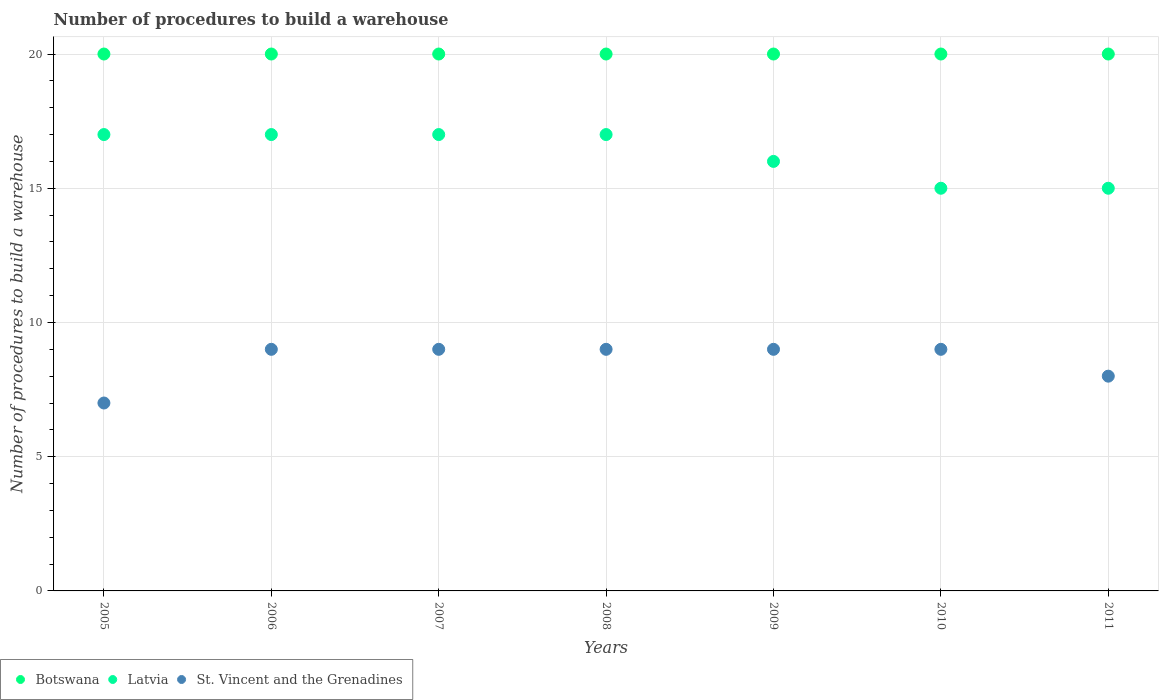Is the number of dotlines equal to the number of legend labels?
Give a very brief answer. Yes. What is the number of procedures to build a warehouse in in Botswana in 2005?
Offer a very short reply. 20. Across all years, what is the maximum number of procedures to build a warehouse in in Latvia?
Your response must be concise. 17. Across all years, what is the minimum number of procedures to build a warehouse in in Latvia?
Ensure brevity in your answer.  15. What is the total number of procedures to build a warehouse in in Latvia in the graph?
Your response must be concise. 114. What is the difference between the number of procedures to build a warehouse in in Latvia in 2011 and the number of procedures to build a warehouse in in Botswana in 2010?
Your answer should be compact. -5. What is the average number of procedures to build a warehouse in in Latvia per year?
Provide a short and direct response. 16.29. In the year 2005, what is the difference between the number of procedures to build a warehouse in in St. Vincent and the Grenadines and number of procedures to build a warehouse in in Latvia?
Keep it short and to the point. -10. In how many years, is the number of procedures to build a warehouse in in Latvia greater than 2?
Ensure brevity in your answer.  7. What is the ratio of the number of procedures to build a warehouse in in Latvia in 2007 to that in 2008?
Give a very brief answer. 1. What is the difference between the highest and the second highest number of procedures to build a warehouse in in Botswana?
Offer a very short reply. 0. What is the difference between the highest and the lowest number of procedures to build a warehouse in in Botswana?
Offer a terse response. 0. Does the number of procedures to build a warehouse in in Botswana monotonically increase over the years?
Offer a very short reply. No. Is the number of procedures to build a warehouse in in Latvia strictly less than the number of procedures to build a warehouse in in Botswana over the years?
Offer a very short reply. Yes. What is the difference between two consecutive major ticks on the Y-axis?
Give a very brief answer. 5. Are the values on the major ticks of Y-axis written in scientific E-notation?
Your answer should be compact. No. Does the graph contain any zero values?
Your response must be concise. No. How are the legend labels stacked?
Your response must be concise. Horizontal. What is the title of the graph?
Your answer should be very brief. Number of procedures to build a warehouse. Does "Heavily indebted poor countries" appear as one of the legend labels in the graph?
Give a very brief answer. No. What is the label or title of the Y-axis?
Give a very brief answer. Number of procedures to build a warehouse. What is the Number of procedures to build a warehouse in St. Vincent and the Grenadines in 2005?
Offer a very short reply. 7. What is the Number of procedures to build a warehouse in Botswana in 2006?
Provide a short and direct response. 20. What is the Number of procedures to build a warehouse of Latvia in 2006?
Provide a short and direct response. 17. What is the Number of procedures to build a warehouse in St. Vincent and the Grenadines in 2006?
Keep it short and to the point. 9. What is the Number of procedures to build a warehouse in Botswana in 2007?
Your answer should be very brief. 20. What is the Number of procedures to build a warehouse in Latvia in 2007?
Ensure brevity in your answer.  17. What is the Number of procedures to build a warehouse of St. Vincent and the Grenadines in 2007?
Give a very brief answer. 9. What is the Number of procedures to build a warehouse in St. Vincent and the Grenadines in 2009?
Your answer should be compact. 9. What is the Number of procedures to build a warehouse in Latvia in 2010?
Your response must be concise. 15. What is the Number of procedures to build a warehouse in Botswana in 2011?
Give a very brief answer. 20. What is the Number of procedures to build a warehouse of Latvia in 2011?
Provide a short and direct response. 15. Across all years, what is the maximum Number of procedures to build a warehouse of Latvia?
Provide a succinct answer. 17. Across all years, what is the maximum Number of procedures to build a warehouse in St. Vincent and the Grenadines?
Make the answer very short. 9. Across all years, what is the minimum Number of procedures to build a warehouse of Botswana?
Offer a terse response. 20. What is the total Number of procedures to build a warehouse of Botswana in the graph?
Give a very brief answer. 140. What is the total Number of procedures to build a warehouse of Latvia in the graph?
Keep it short and to the point. 114. What is the difference between the Number of procedures to build a warehouse of Latvia in 2005 and that in 2006?
Give a very brief answer. 0. What is the difference between the Number of procedures to build a warehouse in Latvia in 2005 and that in 2007?
Your answer should be compact. 0. What is the difference between the Number of procedures to build a warehouse of Latvia in 2005 and that in 2008?
Your answer should be very brief. 0. What is the difference between the Number of procedures to build a warehouse in Latvia in 2005 and that in 2009?
Ensure brevity in your answer.  1. What is the difference between the Number of procedures to build a warehouse of Latvia in 2005 and that in 2010?
Offer a very short reply. 2. What is the difference between the Number of procedures to build a warehouse in Botswana in 2005 and that in 2011?
Keep it short and to the point. 0. What is the difference between the Number of procedures to build a warehouse of Latvia in 2006 and that in 2007?
Provide a short and direct response. 0. What is the difference between the Number of procedures to build a warehouse of St. Vincent and the Grenadines in 2006 and that in 2008?
Your answer should be very brief. 0. What is the difference between the Number of procedures to build a warehouse of Latvia in 2006 and that in 2009?
Your answer should be very brief. 1. What is the difference between the Number of procedures to build a warehouse in St. Vincent and the Grenadines in 2006 and that in 2010?
Your response must be concise. 0. What is the difference between the Number of procedures to build a warehouse in Latvia in 2006 and that in 2011?
Your answer should be very brief. 2. What is the difference between the Number of procedures to build a warehouse in St. Vincent and the Grenadines in 2006 and that in 2011?
Keep it short and to the point. 1. What is the difference between the Number of procedures to build a warehouse in Botswana in 2007 and that in 2008?
Make the answer very short. 0. What is the difference between the Number of procedures to build a warehouse of Latvia in 2007 and that in 2008?
Ensure brevity in your answer.  0. What is the difference between the Number of procedures to build a warehouse in Botswana in 2007 and that in 2009?
Your response must be concise. 0. What is the difference between the Number of procedures to build a warehouse of Latvia in 2007 and that in 2009?
Make the answer very short. 1. What is the difference between the Number of procedures to build a warehouse of St. Vincent and the Grenadines in 2007 and that in 2009?
Keep it short and to the point. 0. What is the difference between the Number of procedures to build a warehouse of Latvia in 2007 and that in 2010?
Ensure brevity in your answer.  2. What is the difference between the Number of procedures to build a warehouse in St. Vincent and the Grenadines in 2007 and that in 2010?
Make the answer very short. 0. What is the difference between the Number of procedures to build a warehouse in Latvia in 2007 and that in 2011?
Keep it short and to the point. 2. What is the difference between the Number of procedures to build a warehouse of Latvia in 2008 and that in 2009?
Offer a terse response. 1. What is the difference between the Number of procedures to build a warehouse of St. Vincent and the Grenadines in 2008 and that in 2009?
Offer a very short reply. 0. What is the difference between the Number of procedures to build a warehouse of Botswana in 2008 and that in 2010?
Offer a terse response. 0. What is the difference between the Number of procedures to build a warehouse of Botswana in 2008 and that in 2011?
Your answer should be very brief. 0. What is the difference between the Number of procedures to build a warehouse of Latvia in 2008 and that in 2011?
Provide a short and direct response. 2. What is the difference between the Number of procedures to build a warehouse in St. Vincent and the Grenadines in 2008 and that in 2011?
Give a very brief answer. 1. What is the difference between the Number of procedures to build a warehouse of St. Vincent and the Grenadines in 2009 and that in 2010?
Offer a very short reply. 0. What is the difference between the Number of procedures to build a warehouse of Botswana in 2009 and that in 2011?
Your response must be concise. 0. What is the difference between the Number of procedures to build a warehouse of Latvia in 2009 and that in 2011?
Your answer should be very brief. 1. What is the difference between the Number of procedures to build a warehouse in Botswana in 2010 and that in 2011?
Provide a short and direct response. 0. What is the difference between the Number of procedures to build a warehouse of Botswana in 2005 and the Number of procedures to build a warehouse of Latvia in 2006?
Keep it short and to the point. 3. What is the difference between the Number of procedures to build a warehouse of Botswana in 2005 and the Number of procedures to build a warehouse of St. Vincent and the Grenadines in 2006?
Give a very brief answer. 11. What is the difference between the Number of procedures to build a warehouse in Botswana in 2005 and the Number of procedures to build a warehouse in Latvia in 2007?
Offer a terse response. 3. What is the difference between the Number of procedures to build a warehouse in Botswana in 2005 and the Number of procedures to build a warehouse in St. Vincent and the Grenadines in 2007?
Offer a terse response. 11. What is the difference between the Number of procedures to build a warehouse of Latvia in 2005 and the Number of procedures to build a warehouse of St. Vincent and the Grenadines in 2007?
Your response must be concise. 8. What is the difference between the Number of procedures to build a warehouse of Latvia in 2005 and the Number of procedures to build a warehouse of St. Vincent and the Grenadines in 2008?
Provide a short and direct response. 8. What is the difference between the Number of procedures to build a warehouse of Latvia in 2005 and the Number of procedures to build a warehouse of St. Vincent and the Grenadines in 2009?
Ensure brevity in your answer.  8. What is the difference between the Number of procedures to build a warehouse of Latvia in 2005 and the Number of procedures to build a warehouse of St. Vincent and the Grenadines in 2010?
Give a very brief answer. 8. What is the difference between the Number of procedures to build a warehouse in Botswana in 2005 and the Number of procedures to build a warehouse in Latvia in 2011?
Offer a very short reply. 5. What is the difference between the Number of procedures to build a warehouse in Botswana in 2005 and the Number of procedures to build a warehouse in St. Vincent and the Grenadines in 2011?
Keep it short and to the point. 12. What is the difference between the Number of procedures to build a warehouse of Latvia in 2005 and the Number of procedures to build a warehouse of St. Vincent and the Grenadines in 2011?
Provide a short and direct response. 9. What is the difference between the Number of procedures to build a warehouse of Botswana in 2006 and the Number of procedures to build a warehouse of Latvia in 2007?
Your response must be concise. 3. What is the difference between the Number of procedures to build a warehouse of Botswana in 2006 and the Number of procedures to build a warehouse of St. Vincent and the Grenadines in 2007?
Make the answer very short. 11. What is the difference between the Number of procedures to build a warehouse of Botswana in 2006 and the Number of procedures to build a warehouse of St. Vincent and the Grenadines in 2008?
Your answer should be compact. 11. What is the difference between the Number of procedures to build a warehouse of Latvia in 2006 and the Number of procedures to build a warehouse of St. Vincent and the Grenadines in 2008?
Provide a short and direct response. 8. What is the difference between the Number of procedures to build a warehouse of Botswana in 2006 and the Number of procedures to build a warehouse of Latvia in 2009?
Ensure brevity in your answer.  4. What is the difference between the Number of procedures to build a warehouse of Botswana in 2006 and the Number of procedures to build a warehouse of Latvia in 2010?
Your response must be concise. 5. What is the difference between the Number of procedures to build a warehouse in Botswana in 2006 and the Number of procedures to build a warehouse in St. Vincent and the Grenadines in 2011?
Your answer should be compact. 12. What is the difference between the Number of procedures to build a warehouse in Latvia in 2006 and the Number of procedures to build a warehouse in St. Vincent and the Grenadines in 2011?
Your answer should be very brief. 9. What is the difference between the Number of procedures to build a warehouse in Latvia in 2007 and the Number of procedures to build a warehouse in St. Vincent and the Grenadines in 2009?
Keep it short and to the point. 8. What is the difference between the Number of procedures to build a warehouse in Botswana in 2007 and the Number of procedures to build a warehouse in St. Vincent and the Grenadines in 2010?
Your response must be concise. 11. What is the difference between the Number of procedures to build a warehouse in Botswana in 2007 and the Number of procedures to build a warehouse in St. Vincent and the Grenadines in 2011?
Give a very brief answer. 12. What is the difference between the Number of procedures to build a warehouse in Botswana in 2008 and the Number of procedures to build a warehouse in Latvia in 2009?
Your answer should be very brief. 4. What is the difference between the Number of procedures to build a warehouse of Botswana in 2008 and the Number of procedures to build a warehouse of St. Vincent and the Grenadines in 2009?
Make the answer very short. 11. What is the difference between the Number of procedures to build a warehouse in Botswana in 2008 and the Number of procedures to build a warehouse in Latvia in 2010?
Offer a terse response. 5. What is the difference between the Number of procedures to build a warehouse of Botswana in 2008 and the Number of procedures to build a warehouse of Latvia in 2011?
Ensure brevity in your answer.  5. What is the difference between the Number of procedures to build a warehouse of Latvia in 2009 and the Number of procedures to build a warehouse of St. Vincent and the Grenadines in 2010?
Keep it short and to the point. 7. What is the difference between the Number of procedures to build a warehouse of Botswana in 2010 and the Number of procedures to build a warehouse of St. Vincent and the Grenadines in 2011?
Your answer should be very brief. 12. What is the difference between the Number of procedures to build a warehouse in Latvia in 2010 and the Number of procedures to build a warehouse in St. Vincent and the Grenadines in 2011?
Provide a succinct answer. 7. What is the average Number of procedures to build a warehouse in Latvia per year?
Make the answer very short. 16.29. What is the average Number of procedures to build a warehouse in St. Vincent and the Grenadines per year?
Your answer should be very brief. 8.57. In the year 2005, what is the difference between the Number of procedures to build a warehouse in Botswana and Number of procedures to build a warehouse in St. Vincent and the Grenadines?
Give a very brief answer. 13. In the year 2005, what is the difference between the Number of procedures to build a warehouse in Latvia and Number of procedures to build a warehouse in St. Vincent and the Grenadines?
Provide a succinct answer. 10. In the year 2009, what is the difference between the Number of procedures to build a warehouse of Botswana and Number of procedures to build a warehouse of Latvia?
Ensure brevity in your answer.  4. In the year 2009, what is the difference between the Number of procedures to build a warehouse in Latvia and Number of procedures to build a warehouse in St. Vincent and the Grenadines?
Give a very brief answer. 7. In the year 2010, what is the difference between the Number of procedures to build a warehouse of Botswana and Number of procedures to build a warehouse of Latvia?
Your answer should be compact. 5. In the year 2010, what is the difference between the Number of procedures to build a warehouse in Latvia and Number of procedures to build a warehouse in St. Vincent and the Grenadines?
Provide a succinct answer. 6. In the year 2011, what is the difference between the Number of procedures to build a warehouse in Botswana and Number of procedures to build a warehouse in Latvia?
Provide a succinct answer. 5. In the year 2011, what is the difference between the Number of procedures to build a warehouse in Latvia and Number of procedures to build a warehouse in St. Vincent and the Grenadines?
Make the answer very short. 7. What is the ratio of the Number of procedures to build a warehouse in Botswana in 2005 to that in 2006?
Provide a succinct answer. 1. What is the ratio of the Number of procedures to build a warehouse in Latvia in 2005 to that in 2006?
Your response must be concise. 1. What is the ratio of the Number of procedures to build a warehouse of Latvia in 2005 to that in 2007?
Offer a very short reply. 1. What is the ratio of the Number of procedures to build a warehouse in Latvia in 2005 to that in 2009?
Ensure brevity in your answer.  1.06. What is the ratio of the Number of procedures to build a warehouse in St. Vincent and the Grenadines in 2005 to that in 2009?
Provide a short and direct response. 0.78. What is the ratio of the Number of procedures to build a warehouse in Botswana in 2005 to that in 2010?
Provide a short and direct response. 1. What is the ratio of the Number of procedures to build a warehouse in Latvia in 2005 to that in 2010?
Offer a very short reply. 1.13. What is the ratio of the Number of procedures to build a warehouse of St. Vincent and the Grenadines in 2005 to that in 2010?
Provide a succinct answer. 0.78. What is the ratio of the Number of procedures to build a warehouse of Latvia in 2005 to that in 2011?
Offer a very short reply. 1.13. What is the ratio of the Number of procedures to build a warehouse of St. Vincent and the Grenadines in 2005 to that in 2011?
Keep it short and to the point. 0.88. What is the ratio of the Number of procedures to build a warehouse in Botswana in 2006 to that in 2007?
Your response must be concise. 1. What is the ratio of the Number of procedures to build a warehouse of Botswana in 2006 to that in 2009?
Offer a very short reply. 1. What is the ratio of the Number of procedures to build a warehouse of St. Vincent and the Grenadines in 2006 to that in 2009?
Provide a short and direct response. 1. What is the ratio of the Number of procedures to build a warehouse in Latvia in 2006 to that in 2010?
Your response must be concise. 1.13. What is the ratio of the Number of procedures to build a warehouse of St. Vincent and the Grenadines in 2006 to that in 2010?
Offer a very short reply. 1. What is the ratio of the Number of procedures to build a warehouse in Latvia in 2006 to that in 2011?
Your answer should be compact. 1.13. What is the ratio of the Number of procedures to build a warehouse of Latvia in 2007 to that in 2008?
Give a very brief answer. 1. What is the ratio of the Number of procedures to build a warehouse in St. Vincent and the Grenadines in 2007 to that in 2008?
Your answer should be compact. 1. What is the ratio of the Number of procedures to build a warehouse in Botswana in 2007 to that in 2009?
Offer a very short reply. 1. What is the ratio of the Number of procedures to build a warehouse of St. Vincent and the Grenadines in 2007 to that in 2009?
Make the answer very short. 1. What is the ratio of the Number of procedures to build a warehouse of Botswana in 2007 to that in 2010?
Keep it short and to the point. 1. What is the ratio of the Number of procedures to build a warehouse of Latvia in 2007 to that in 2010?
Provide a short and direct response. 1.13. What is the ratio of the Number of procedures to build a warehouse of St. Vincent and the Grenadines in 2007 to that in 2010?
Offer a terse response. 1. What is the ratio of the Number of procedures to build a warehouse in Latvia in 2007 to that in 2011?
Ensure brevity in your answer.  1.13. What is the ratio of the Number of procedures to build a warehouse in Botswana in 2008 to that in 2009?
Give a very brief answer. 1. What is the ratio of the Number of procedures to build a warehouse of St. Vincent and the Grenadines in 2008 to that in 2009?
Offer a very short reply. 1. What is the ratio of the Number of procedures to build a warehouse in Botswana in 2008 to that in 2010?
Your answer should be compact. 1. What is the ratio of the Number of procedures to build a warehouse of Latvia in 2008 to that in 2010?
Your response must be concise. 1.13. What is the ratio of the Number of procedures to build a warehouse of Latvia in 2008 to that in 2011?
Offer a terse response. 1.13. What is the ratio of the Number of procedures to build a warehouse of St. Vincent and the Grenadines in 2008 to that in 2011?
Keep it short and to the point. 1.12. What is the ratio of the Number of procedures to build a warehouse in Botswana in 2009 to that in 2010?
Your answer should be compact. 1. What is the ratio of the Number of procedures to build a warehouse of Latvia in 2009 to that in 2010?
Make the answer very short. 1.07. What is the ratio of the Number of procedures to build a warehouse of Latvia in 2009 to that in 2011?
Your response must be concise. 1.07. What is the ratio of the Number of procedures to build a warehouse of Botswana in 2010 to that in 2011?
Give a very brief answer. 1. What is the difference between the highest and the second highest Number of procedures to build a warehouse in St. Vincent and the Grenadines?
Provide a succinct answer. 0. What is the difference between the highest and the lowest Number of procedures to build a warehouse in Latvia?
Keep it short and to the point. 2. What is the difference between the highest and the lowest Number of procedures to build a warehouse of St. Vincent and the Grenadines?
Provide a short and direct response. 2. 